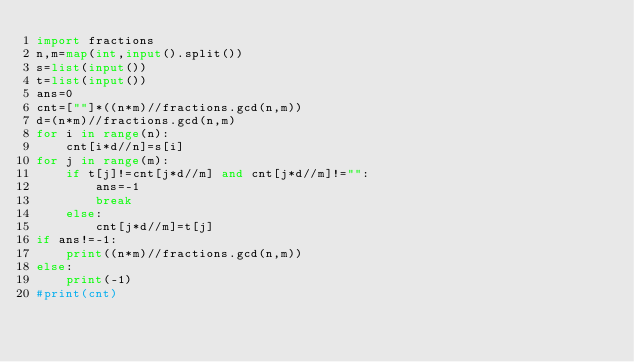Convert code to text. <code><loc_0><loc_0><loc_500><loc_500><_Python_>import fractions
n,m=map(int,input().split())
s=list(input())
t=list(input())
ans=0
cnt=[""]*((n*m)//fractions.gcd(n,m))
d=(n*m)//fractions.gcd(n,m)
for i in range(n):
    cnt[i*d//n]=s[i]
for j in range(m):
    if t[j]!=cnt[j*d//m] and cnt[j*d//m]!="":
        ans=-1
        break
    else:
        cnt[j*d//m]=t[j]
if ans!=-1:
    print((n*m)//fractions.gcd(n,m))
else:
    print(-1)
#print(cnt)</code> 